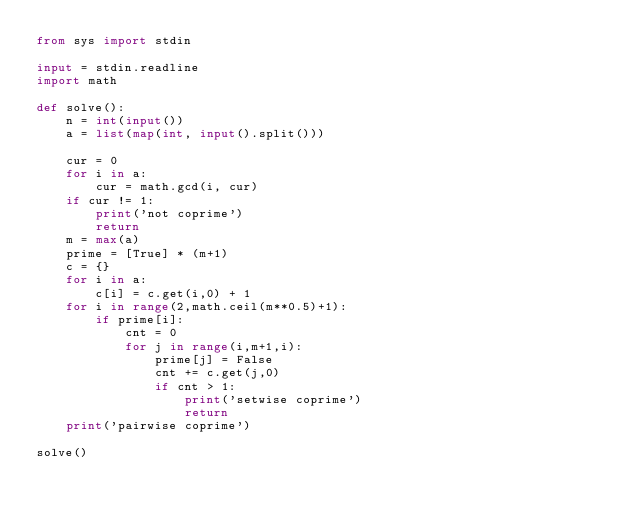Convert code to text. <code><loc_0><loc_0><loc_500><loc_500><_Python_>from sys import stdin

input = stdin.readline
import math

def solve():
    n = int(input())
    a = list(map(int, input().split()))

    cur = 0
    for i in a:
        cur = math.gcd(i, cur)
    if cur != 1:
        print('not coprime')
        return
    m = max(a)
    prime = [True] * (m+1)
    c = {}
    for i in a:
        c[i] = c.get(i,0) + 1
    for i in range(2,math.ceil(m**0.5)+1):
        if prime[i]:
            cnt = 0
            for j in range(i,m+1,i):
                prime[j] = False
                cnt += c.get(j,0)
                if cnt > 1:
                    print('setwise coprime')
                    return
    print('pairwise coprime')

solve()
</code> 